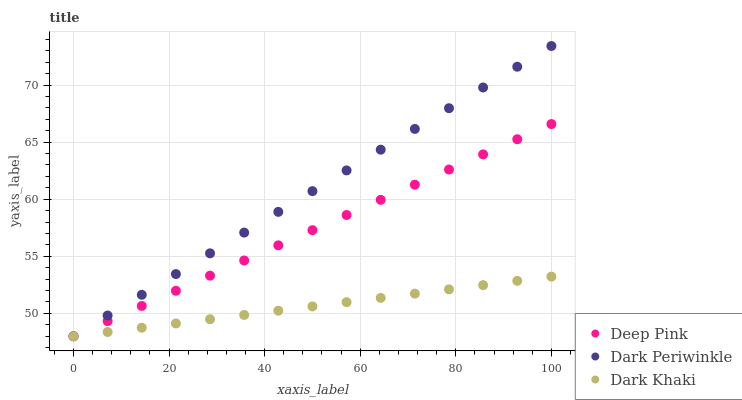Does Dark Khaki have the minimum area under the curve?
Answer yes or no. Yes. Does Dark Periwinkle have the maximum area under the curve?
Answer yes or no. Yes. Does Deep Pink have the minimum area under the curve?
Answer yes or no. No. Does Deep Pink have the maximum area under the curve?
Answer yes or no. No. Is Dark Khaki the smoothest?
Answer yes or no. Yes. Is Dark Periwinkle the roughest?
Answer yes or no. Yes. Is Deep Pink the smoothest?
Answer yes or no. No. Is Deep Pink the roughest?
Answer yes or no. No. Does Dark Khaki have the lowest value?
Answer yes or no. Yes. Does Dark Periwinkle have the highest value?
Answer yes or no. Yes. Does Deep Pink have the highest value?
Answer yes or no. No. Does Dark Khaki intersect Dark Periwinkle?
Answer yes or no. Yes. Is Dark Khaki less than Dark Periwinkle?
Answer yes or no. No. Is Dark Khaki greater than Dark Periwinkle?
Answer yes or no. No. 